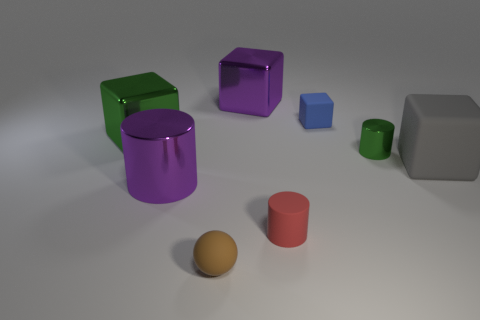Subtract 1 cylinders. How many cylinders are left? 2 Add 1 purple spheres. How many objects exist? 9 Subtract all brown blocks. Subtract all green spheres. How many blocks are left? 4 Subtract all spheres. How many objects are left? 7 Add 5 big brown shiny spheres. How many big brown shiny spheres exist? 5 Subtract 0 red blocks. How many objects are left? 8 Subtract all large green metal objects. Subtract all tiny green metal cylinders. How many objects are left? 6 Add 4 matte objects. How many matte objects are left? 8 